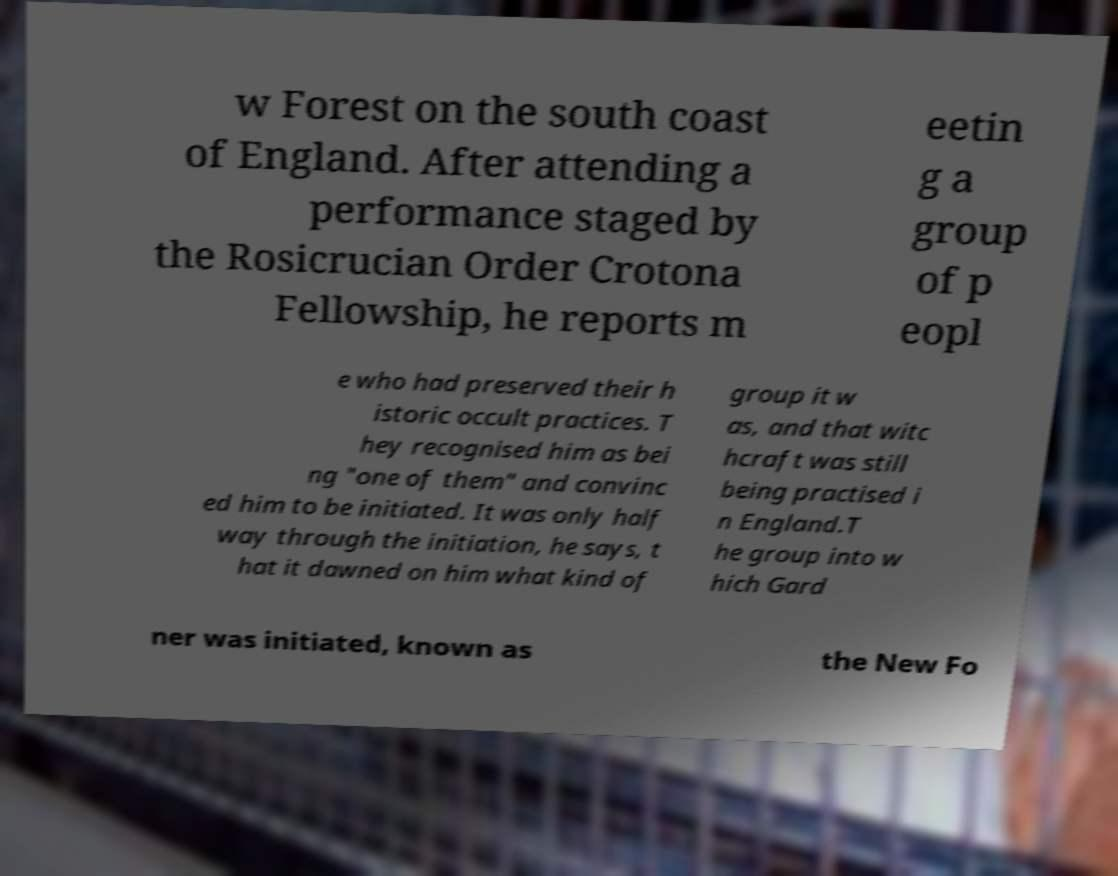What messages or text are displayed in this image? I need them in a readable, typed format. w Forest on the south coast of England. After attending a performance staged by the Rosicrucian Order Crotona Fellowship, he reports m eetin g a group of p eopl e who had preserved their h istoric occult practices. T hey recognised him as bei ng "one of them" and convinc ed him to be initiated. It was only half way through the initiation, he says, t hat it dawned on him what kind of group it w as, and that witc hcraft was still being practised i n England.T he group into w hich Gard ner was initiated, known as the New Fo 